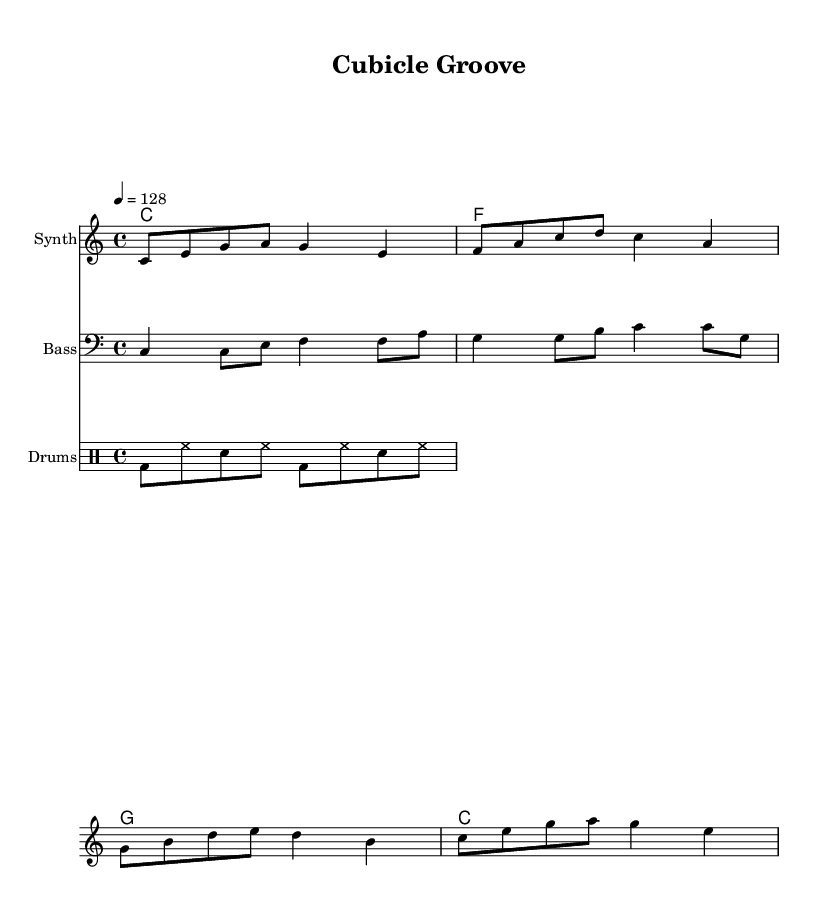What is the key signature of this music? The key signature is indicated at the beginning of the staff. It shows that the music is in C major, which has no sharps or flats.
Answer: C major What is the time signature used in this piece? The time signature is found at the beginning of the piece, showing it as 4/4. This means there are four beats in each measure, and a quarter note gets one beat.
Answer: 4/4 What is the tempo for this piece? The tempo marking appears near the top, stating that it should be played at a speed of 128 beats per minute. This is indicated with "4 = 128."
Answer: 128 How many measures are there in the synthesizer part? To find the number of measures, count the lines and the number of groups of notes separated by bar lines. There are 4 measures in the synthesizer music section presented.
Answer: 4 What chords are played in this piece? The chords are listed at the beginning of each section, showing C, F, G, and C again. These chords repeat and provide the harmonic structure for the piece.
Answer: C, F, G Which instrument has a bass clef? The instrument that requires a bass clef is indicated in the staff designation. The bass part is specifically written with a bass clef.
Answer: Bass What instruments are featured in this score? The score includes three separate staves indicating the instruments: Synth, Bass, and Drums. Each staff represents a different instrument being played simultaneously.
Answer: Synth, Bass, Drums 